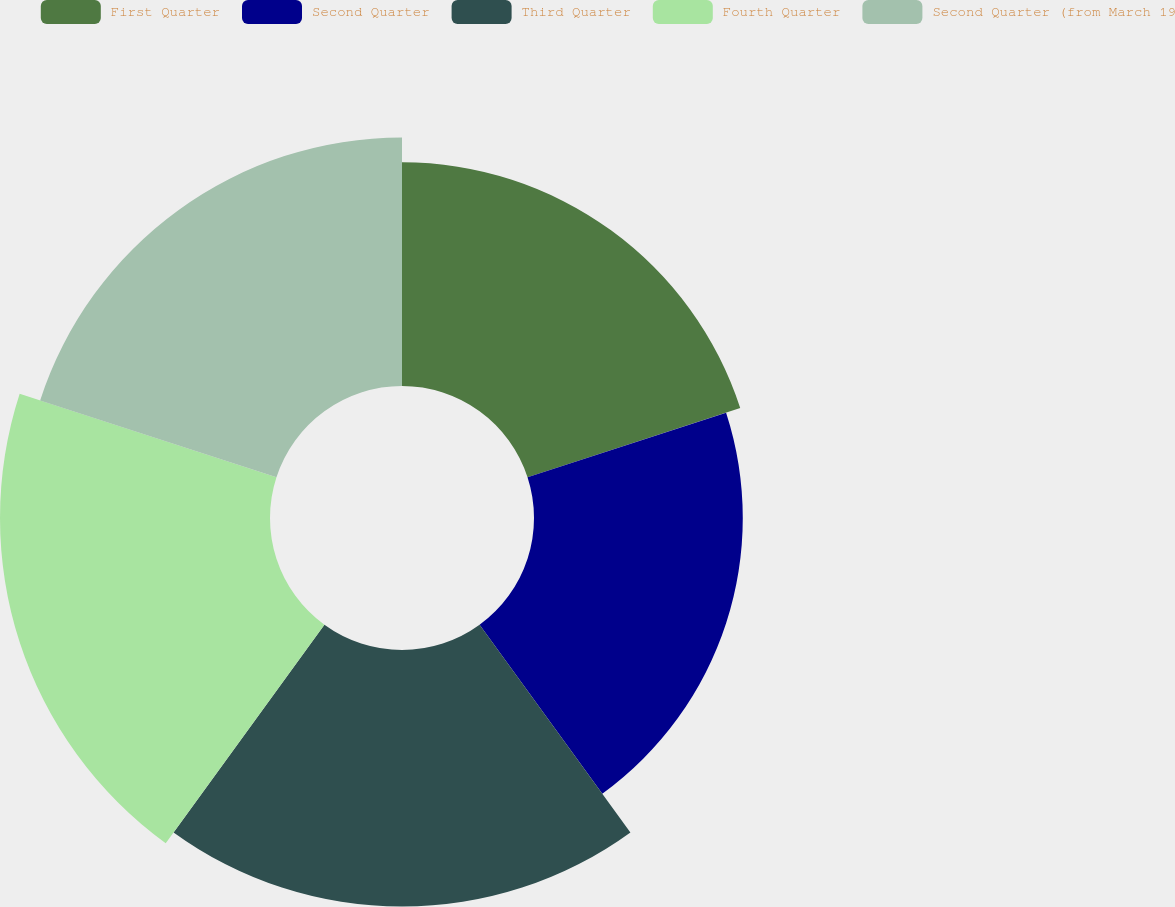Convert chart. <chart><loc_0><loc_0><loc_500><loc_500><pie_chart><fcel>First Quarter<fcel>Second Quarter<fcel>Third Quarter<fcel>Fourth Quarter<fcel>Second Quarter (from March 19<nl><fcel>18.52%<fcel>17.29%<fcel>21.25%<fcel>22.36%<fcel>20.58%<nl></chart> 